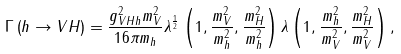<formula> <loc_0><loc_0><loc_500><loc_500>\Gamma \left ( h \rightarrow V H \right ) & = \frac { g _ { V H h } ^ { 2 } m _ { V } ^ { 2 } } { 1 6 \pi m _ { h } } \lambda ^ { \frac { 1 } { 2 } } \left ( 1 , \frac { m _ { V } ^ { 2 } } { m _ { h } ^ { 2 } } , \frac { m _ { H } ^ { 2 } } { m _ { h } ^ { 2 } } \right ) \lambda \left ( 1 , \frac { m _ { h } ^ { 2 } } { m _ { V } ^ { 2 } } , \frac { m _ { H } ^ { 2 } } { m _ { V } ^ { 2 } } \right ) ,</formula> 